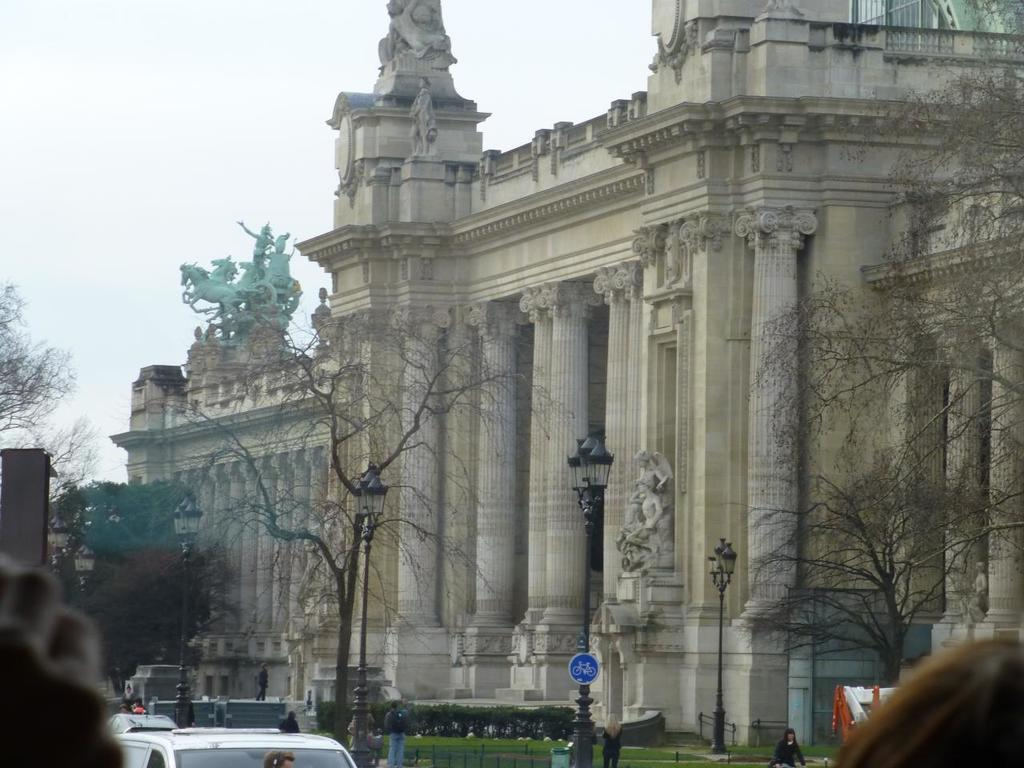What structure is located on the right side of the image? There is a monument on the right side of the image. What type of vegetation is in the middle of the image? There are trees in the middle of the image. What is visible at the top of the image? The sky is visible at the top of the image. What songs are being played by the vase in the image? There is no vase present in the image, and therefore no songs can be heard. Can you describe the skateboarding tricks being performed in the image? There is no skateboarding or any related activity depicted in the image. 